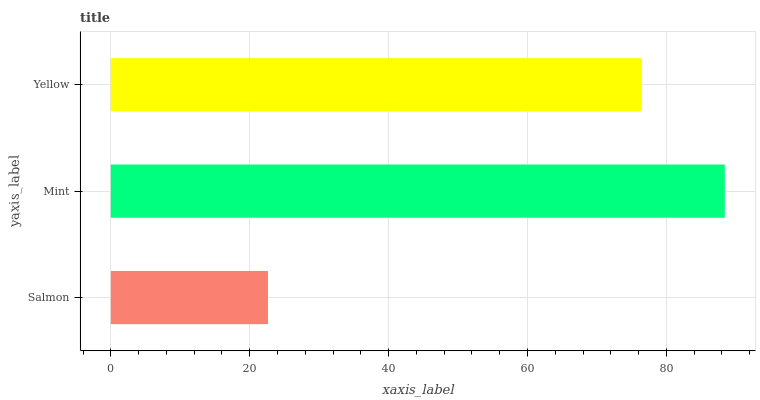Is Salmon the minimum?
Answer yes or no. Yes. Is Mint the maximum?
Answer yes or no. Yes. Is Yellow the minimum?
Answer yes or no. No. Is Yellow the maximum?
Answer yes or no. No. Is Mint greater than Yellow?
Answer yes or no. Yes. Is Yellow less than Mint?
Answer yes or no. Yes. Is Yellow greater than Mint?
Answer yes or no. No. Is Mint less than Yellow?
Answer yes or no. No. Is Yellow the high median?
Answer yes or no. Yes. Is Yellow the low median?
Answer yes or no. Yes. Is Mint the high median?
Answer yes or no. No. Is Mint the low median?
Answer yes or no. No. 